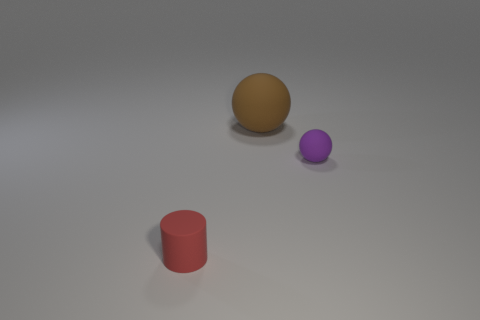Are there more small red objects to the left of the big brown ball than tiny blue spheres?
Give a very brief answer. Yes. What is the size of the other thing that is the same shape as the purple object?
Your response must be concise. Large. What is the shape of the purple rubber object?
Ensure brevity in your answer.  Sphere. What shape is the other thing that is the same size as the purple rubber thing?
Keep it short and to the point. Cylinder. Is there anything else that has the same color as the small matte ball?
Your answer should be compact. No. What is the size of the brown ball that is made of the same material as the small purple thing?
Offer a very short reply. Large. There is a brown matte object; does it have the same shape as the tiny rubber thing that is behind the tiny red matte object?
Your response must be concise. Yes. How big is the brown sphere?
Provide a succinct answer. Large. Is the number of small purple matte spheres that are behind the tiny purple matte object less than the number of green shiny cylinders?
Your answer should be very brief. No. How many brown spheres have the same size as the red rubber cylinder?
Provide a succinct answer. 0. 